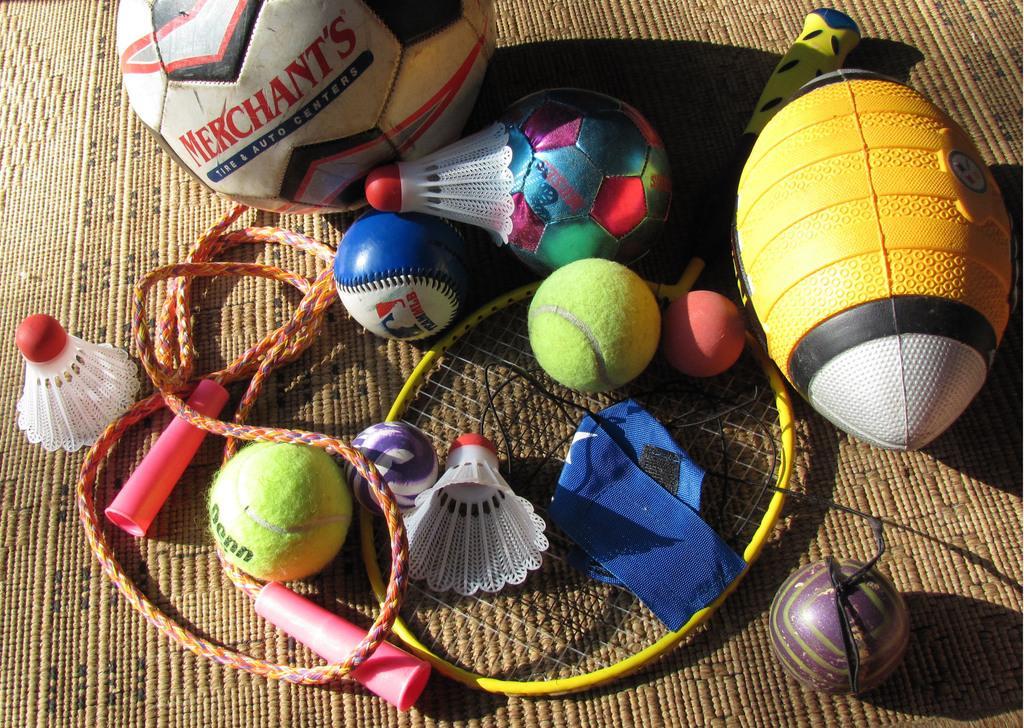Describe this image in one or two sentences. In this image there are corks, skipping rope, balls, shuttle bat on the mat. 